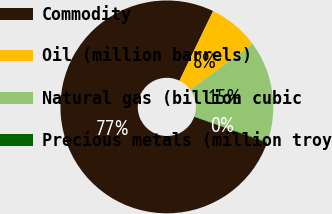Convert chart to OTSL. <chart><loc_0><loc_0><loc_500><loc_500><pie_chart><fcel>Commodity<fcel>Oil (million barrels)<fcel>Natural gas (billion cubic<fcel>Precious metals (million troy<nl><fcel>76.69%<fcel>7.77%<fcel>15.43%<fcel>0.11%<nl></chart> 